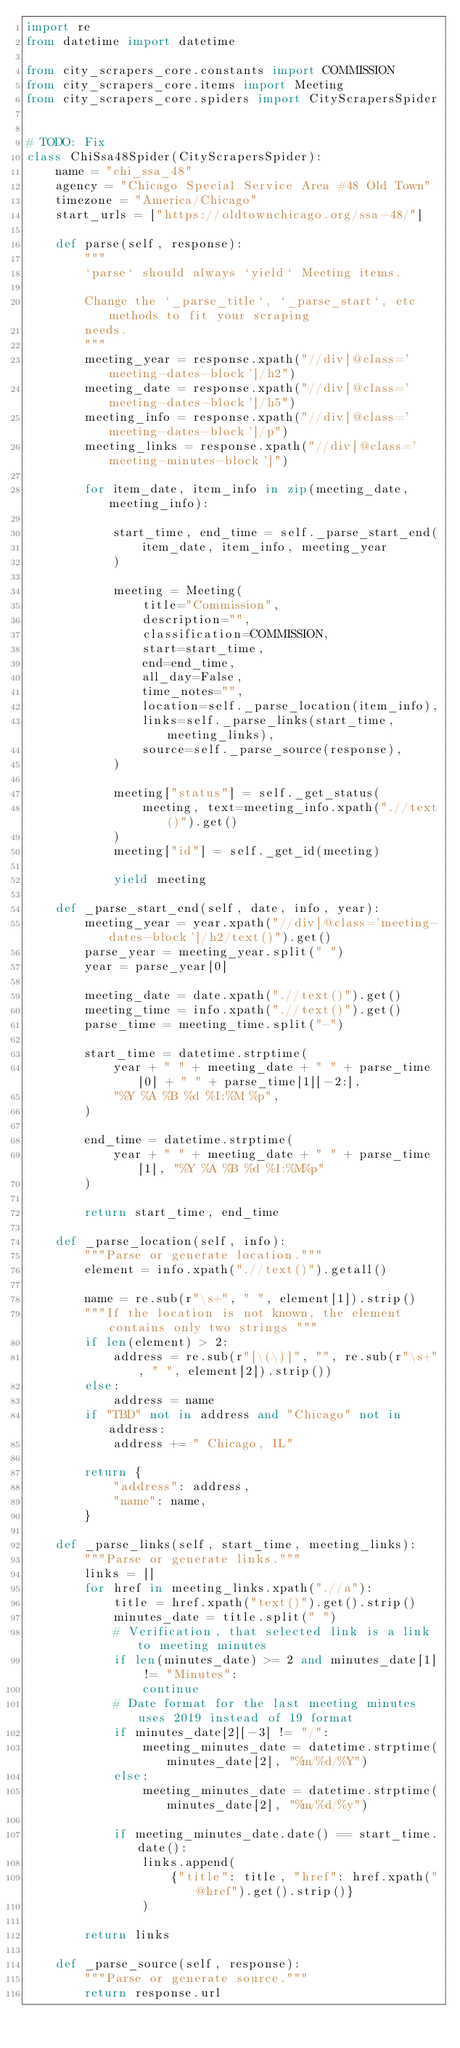<code> <loc_0><loc_0><loc_500><loc_500><_Python_>import re
from datetime import datetime

from city_scrapers_core.constants import COMMISSION
from city_scrapers_core.items import Meeting
from city_scrapers_core.spiders import CityScrapersSpider


# TODO: Fix
class ChiSsa48Spider(CityScrapersSpider):
    name = "chi_ssa_48"
    agency = "Chicago Special Service Area #48 Old Town"
    timezone = "America/Chicago"
    start_urls = ["https://oldtownchicago.org/ssa-48/"]

    def parse(self, response):
        """
        `parse` should always `yield` Meeting items.

        Change the `_parse_title`, `_parse_start`, etc methods to fit your scraping
        needs.
        """
        meeting_year = response.xpath("//div[@class='meeting-dates-block']/h2")
        meeting_date = response.xpath("//div[@class='meeting-dates-block']/h5")
        meeting_info = response.xpath("//div[@class='meeting-dates-block']/p")
        meeting_links = response.xpath("//div[@class='meeting-minutes-block']")

        for item_date, item_info in zip(meeting_date, meeting_info):

            start_time, end_time = self._parse_start_end(
                item_date, item_info, meeting_year
            )

            meeting = Meeting(
                title="Commission",
                description="",
                classification=COMMISSION,
                start=start_time,
                end=end_time,
                all_day=False,
                time_notes="",
                location=self._parse_location(item_info),
                links=self._parse_links(start_time, meeting_links),
                source=self._parse_source(response),
            )

            meeting["status"] = self._get_status(
                meeting, text=meeting_info.xpath(".//text()").get()
            )
            meeting["id"] = self._get_id(meeting)

            yield meeting

    def _parse_start_end(self, date, info, year):
        meeting_year = year.xpath("//div[@class='meeting-dates-block']/h2/text()").get()
        parse_year = meeting_year.split(" ")
        year = parse_year[0]

        meeting_date = date.xpath(".//text()").get()
        meeting_time = info.xpath(".//text()").get()
        parse_time = meeting_time.split("-")

        start_time = datetime.strptime(
            year + " " + meeting_date + " " + parse_time[0] + " " + parse_time[1][-2:],
            "%Y %A %B %d %I:%M %p",
        )

        end_time = datetime.strptime(
            year + " " + meeting_date + " " + parse_time[1], "%Y %A %B %d %I:%M%p"
        )

        return start_time, end_time

    def _parse_location(self, info):
        """Parse or generate location."""
        element = info.xpath(".//text()").getall()

        name = re.sub(r"\s+", " ", element[1]).strip()
        """If the location is not known, the element contains only two strings """
        if len(element) > 2:
            address = re.sub(r"[\(\)]", "", re.sub(r"\s+", " ", element[2]).strip())
        else:
            address = name
        if "TBD" not in address and "Chicago" not in address:
            address += " Chicago, IL"

        return {
            "address": address,
            "name": name,
        }

    def _parse_links(self, start_time, meeting_links):
        """Parse or generate links."""
        links = []
        for href in meeting_links.xpath(".//a"):
            title = href.xpath("text()").get().strip()
            minutes_date = title.split(" ")
            # Verification, that selected link is a link to meeting minutes
            if len(minutes_date) >= 2 and minutes_date[1] != "Minutes":
                continue
            # Date format for the last meeting minutes uses 2019 instead of 19 format
            if minutes_date[2][-3] != "/":
                meeting_minutes_date = datetime.strptime(minutes_date[2], "%m/%d/%Y")
            else:
                meeting_minutes_date = datetime.strptime(minutes_date[2], "%m/%d/%y")

            if meeting_minutes_date.date() == start_time.date():
                links.append(
                    {"title": title, "href": href.xpath("@href").get().strip()}
                )

        return links

    def _parse_source(self, response):
        """Parse or generate source."""
        return response.url
</code> 